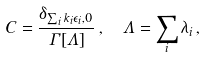Convert formula to latex. <formula><loc_0><loc_0><loc_500><loc_500>C & = \frac { \delta _ { \sum _ { i } k _ { i } \epsilon _ { i } , 0 } } { \Gamma [ \Lambda ] } \, , \quad \Lambda = \sum _ { i } \lambda _ { i } \, ,</formula> 